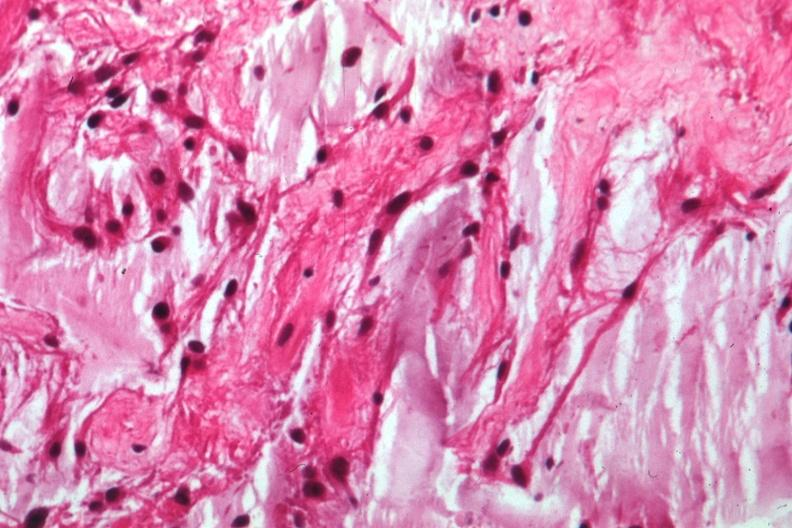s optic nerve present?
Answer the question using a single word or phrase. Yes 